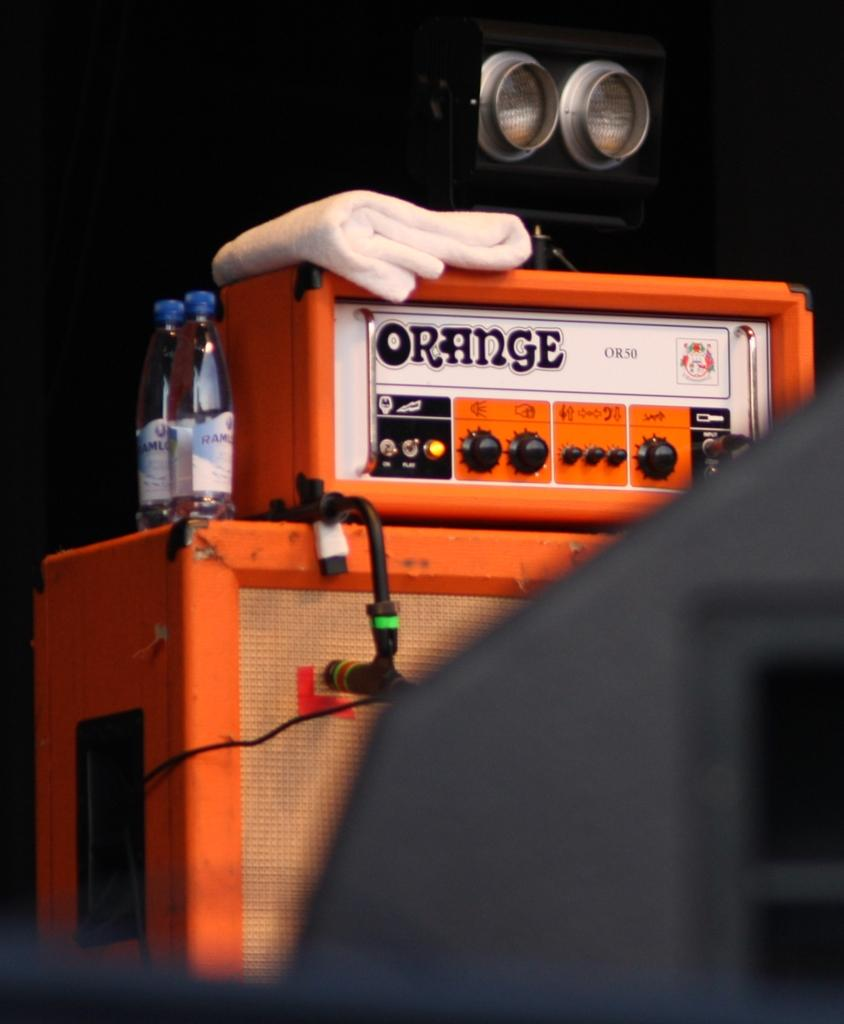What is the main object in the center of the image? There is an electric box in the image, and it is placed at the center. What else can be seen in the image besides the electric box? There are two water bottles in the image, and they are at the left side. What type of glove is being used to manipulate the electric box in the image? There is no glove present in the image, and no one is manipulating the electric box. 